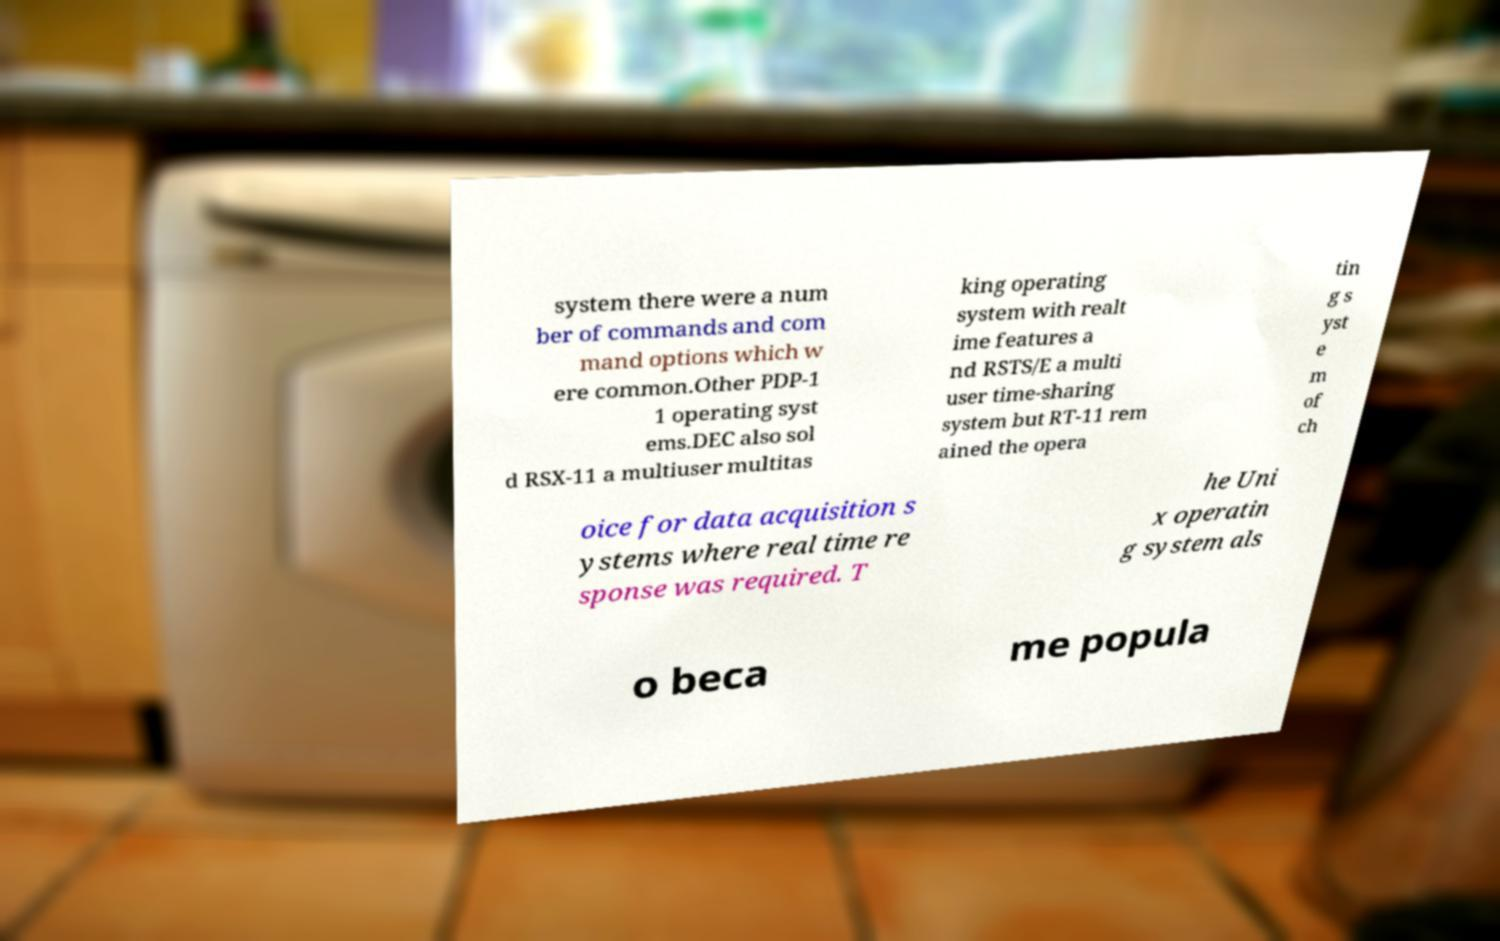What messages or text are displayed in this image? I need them in a readable, typed format. system there were a num ber of commands and com mand options which w ere common.Other PDP-1 1 operating syst ems.DEC also sol d RSX-11 a multiuser multitas king operating system with realt ime features a nd RSTS/E a multi user time-sharing system but RT-11 rem ained the opera tin g s yst e m of ch oice for data acquisition s ystems where real time re sponse was required. T he Uni x operatin g system als o beca me popula 